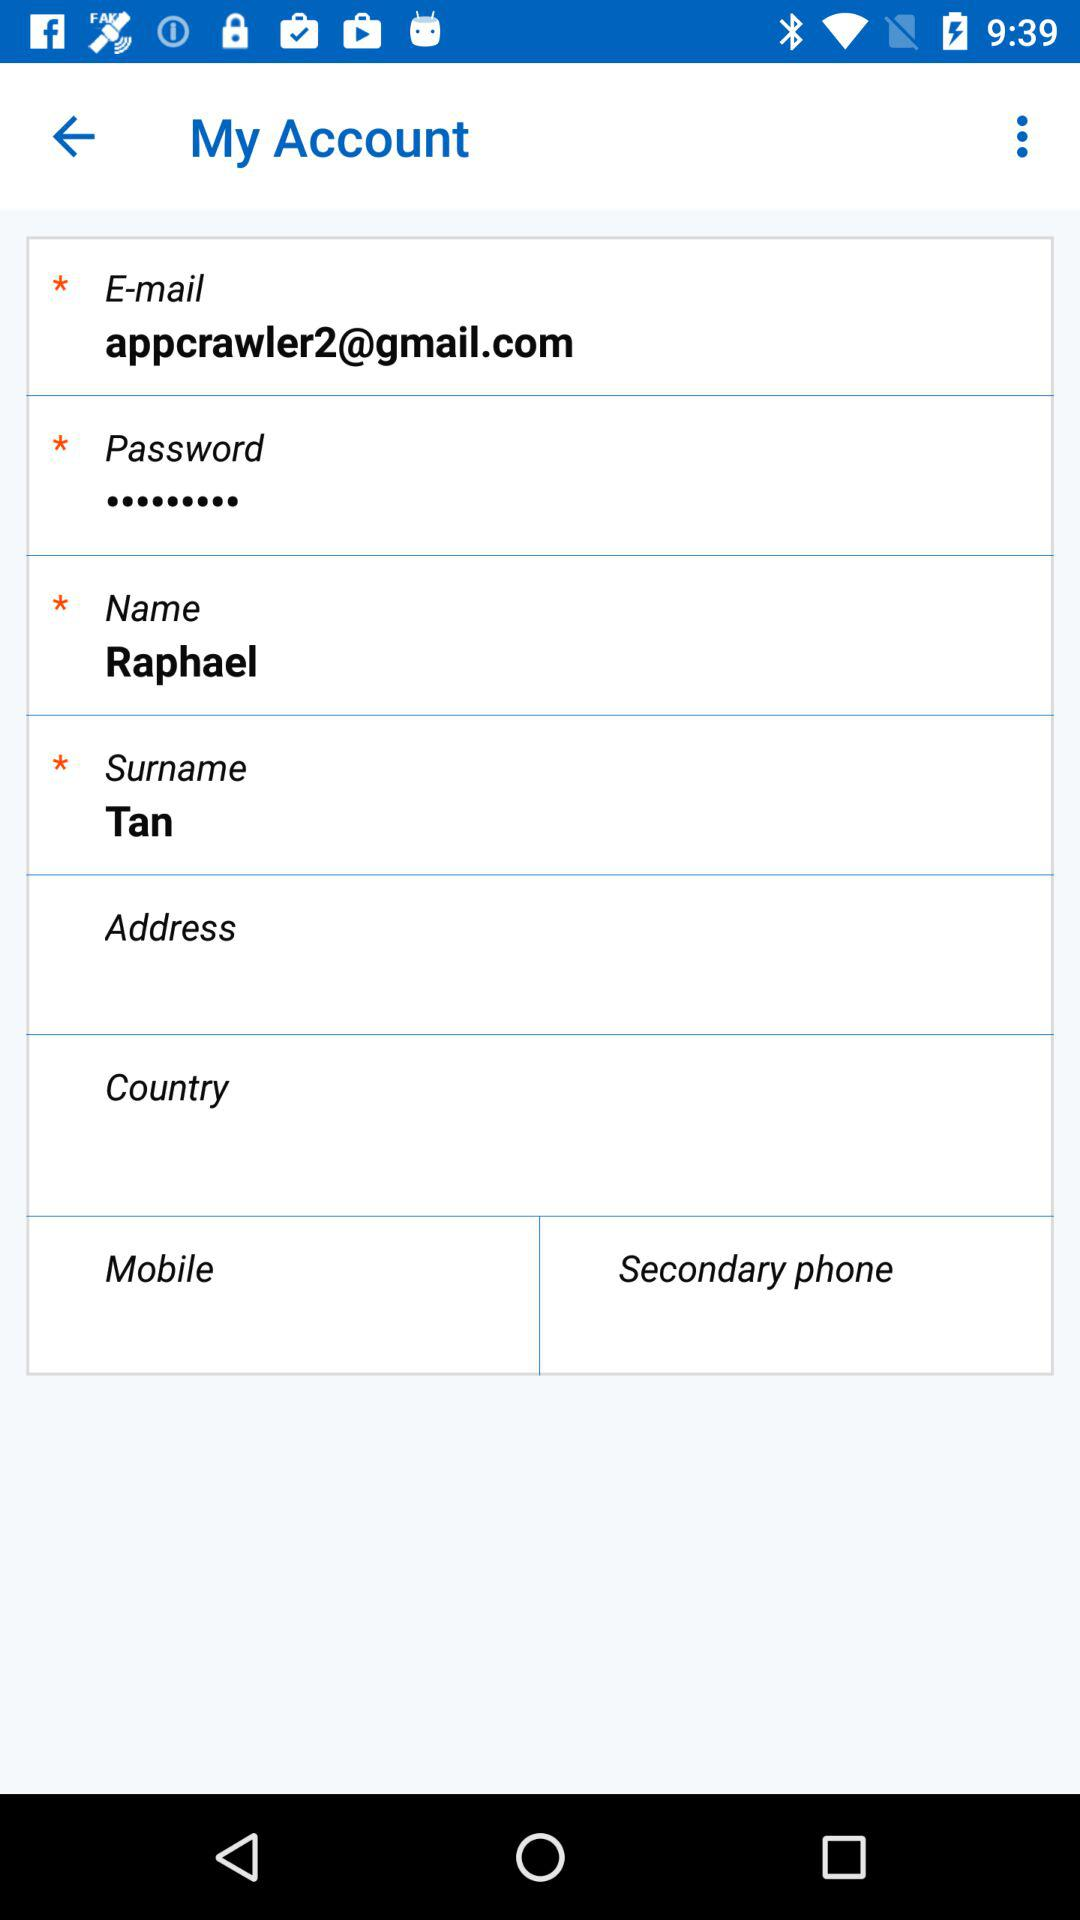What name is given? The given name is Raphael Tan. 